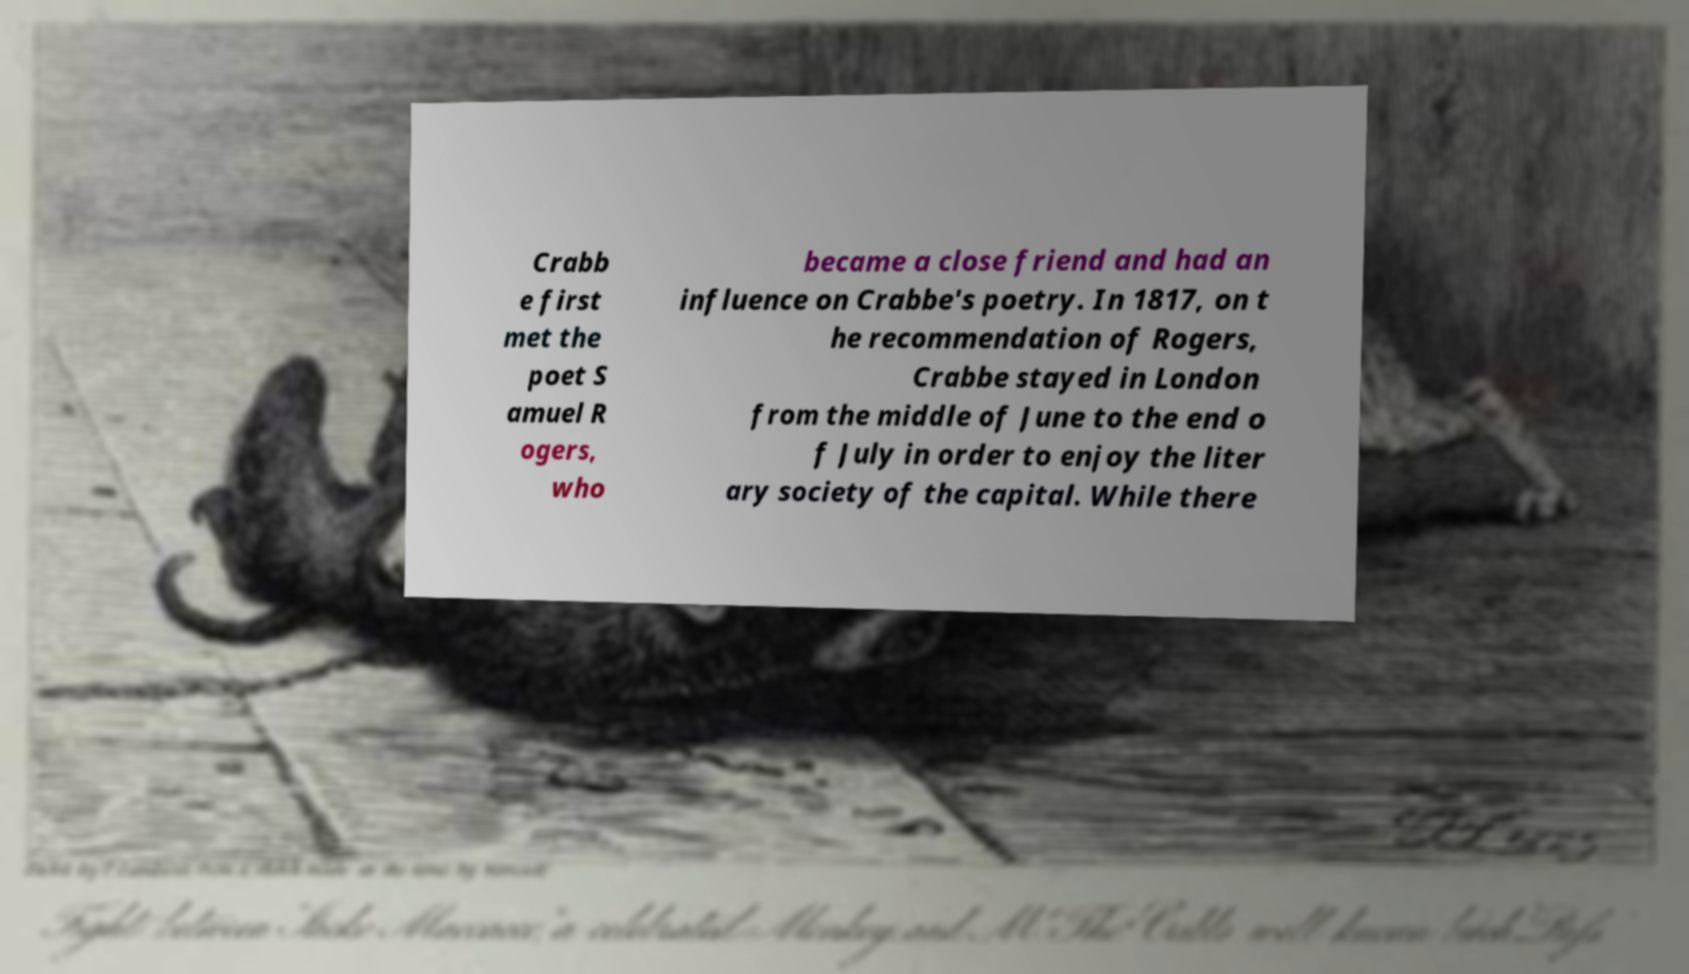Can you accurately transcribe the text from the provided image for me? Crabb e first met the poet S amuel R ogers, who became a close friend and had an influence on Crabbe's poetry. In 1817, on t he recommendation of Rogers, Crabbe stayed in London from the middle of June to the end o f July in order to enjoy the liter ary society of the capital. While there 